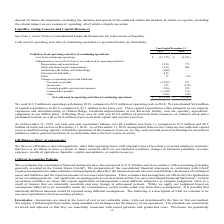From Ricebran Technologies's financial document, What are the respective loss from continuing operations in 2018 and 2019? The document shows two values: 8,101 and 13,735 (in thousands). From the document: "Loss from continuing operations (13,735) $ (8,101) $ Loss from continuing operations (13,735) $ (8,101) $..." Also, What are the respective adjustments to depreciation and amortization in 2018 and 2019? The document shows two values: 773 and 1,930 (in thousands). From the document: "Depreciation and amortization 1,930 773 Depreciation and amortization 1,930 773..." Also, What are the respective adjustments to stock and share-based compensation in 2018 and 2019? The document shows two values: 886 and 1,360 (in thousands). From the document: "Stock and share-based compensation 1,360 886 Stock and share-based compensation 1,360 886..." Also, can you calculate: What is the average loss from continuing operations in 2018 and 2019? To answer this question, I need to perform calculations using the financial data. The calculation is: (8,101 + 13,735)/2 , which equals 10918 (in thousands). This is based on the information: "Loss from continuing operations (13,735) $ (8,101) $ Loss from continuing operations (13,735) $ (8,101) $..." The key data points involved are: 13,735, 8,101. Also, can you calculate: What is the percentage change in adjustment in depreciation and amortization in 2018 and 2019? To answer this question, I need to perform calculations using the financial data. The calculation is: (1,930 - 773)/773 , which equals 149.68 (percentage). This is based on the information: "Depreciation and amortization 1,930 773 Depreciation and amortization 1,930 773..." The key data points involved are: 1,930, 773. Also, can you calculate: What is the percentage change in adjustments to stock and share-based compensation in 2018 and 2019? To answer this question, I need to perform calculations using the financial data. The calculation is: (1,360 - 886)/886 , which equals 53.5 (percentage). This is based on the information: "Stock and share-based compensation 1,360 886 Stock and share-based compensation 1,360 886..." The key data points involved are: 1,360, 886. 